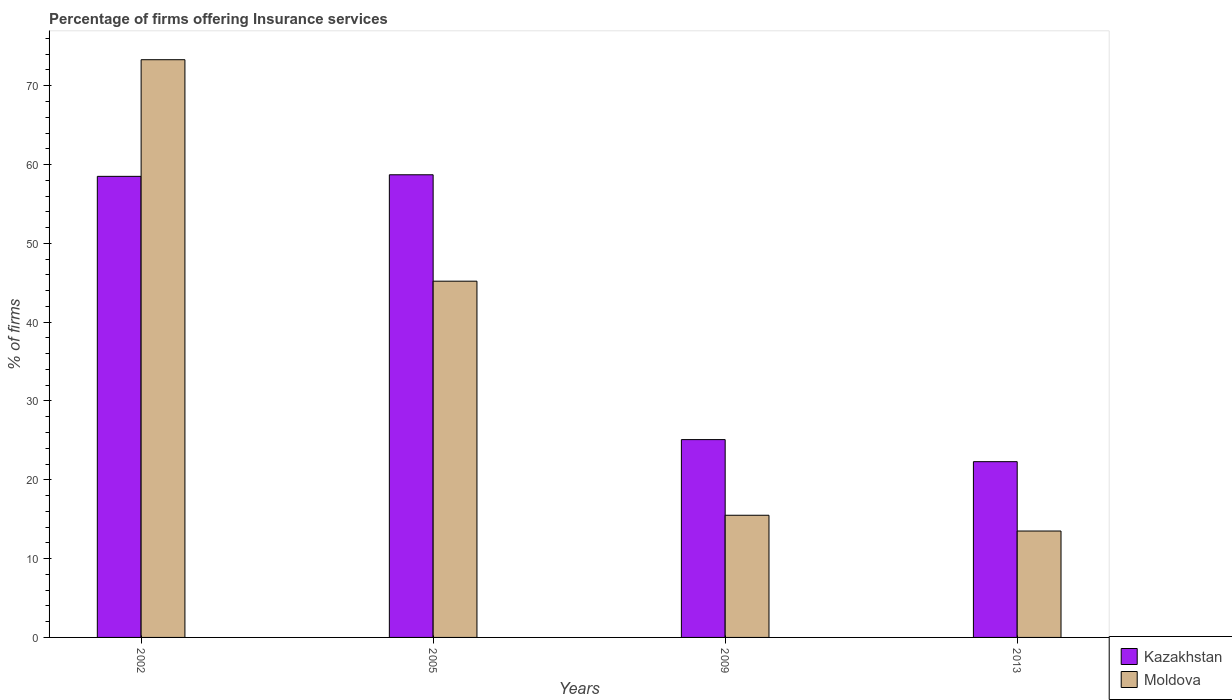How many different coloured bars are there?
Provide a short and direct response. 2. How many groups of bars are there?
Your answer should be compact. 4. Are the number of bars per tick equal to the number of legend labels?
Your answer should be very brief. Yes. How many bars are there on the 1st tick from the right?
Your answer should be very brief. 2. What is the label of the 2nd group of bars from the left?
Provide a short and direct response. 2005. What is the percentage of firms offering insurance services in Moldova in 2005?
Give a very brief answer. 45.2. Across all years, what is the maximum percentage of firms offering insurance services in Moldova?
Keep it short and to the point. 73.3. In which year was the percentage of firms offering insurance services in Kazakhstan maximum?
Ensure brevity in your answer.  2005. In which year was the percentage of firms offering insurance services in Kazakhstan minimum?
Your answer should be compact. 2013. What is the total percentage of firms offering insurance services in Moldova in the graph?
Give a very brief answer. 147.5. What is the difference between the percentage of firms offering insurance services in Moldova in 2002 and that in 2005?
Ensure brevity in your answer.  28.1. What is the difference between the percentage of firms offering insurance services in Kazakhstan in 2005 and the percentage of firms offering insurance services in Moldova in 2013?
Give a very brief answer. 45.2. What is the average percentage of firms offering insurance services in Kazakhstan per year?
Give a very brief answer. 41.15. In how many years, is the percentage of firms offering insurance services in Moldova greater than 30 %?
Provide a short and direct response. 2. What is the ratio of the percentage of firms offering insurance services in Moldova in 2002 to that in 2005?
Ensure brevity in your answer.  1.62. Is the percentage of firms offering insurance services in Kazakhstan in 2002 less than that in 2013?
Offer a very short reply. No. What is the difference between the highest and the second highest percentage of firms offering insurance services in Kazakhstan?
Your response must be concise. 0.2. What is the difference between the highest and the lowest percentage of firms offering insurance services in Kazakhstan?
Your answer should be very brief. 36.4. In how many years, is the percentage of firms offering insurance services in Moldova greater than the average percentage of firms offering insurance services in Moldova taken over all years?
Provide a succinct answer. 2. Is the sum of the percentage of firms offering insurance services in Kazakhstan in 2005 and 2013 greater than the maximum percentage of firms offering insurance services in Moldova across all years?
Your answer should be compact. Yes. What does the 1st bar from the left in 2013 represents?
Offer a terse response. Kazakhstan. What does the 2nd bar from the right in 2002 represents?
Your answer should be very brief. Kazakhstan. How many bars are there?
Your answer should be compact. 8. How many years are there in the graph?
Provide a succinct answer. 4. Are the values on the major ticks of Y-axis written in scientific E-notation?
Offer a terse response. No. Does the graph contain grids?
Provide a short and direct response. No. How many legend labels are there?
Offer a very short reply. 2. What is the title of the graph?
Offer a very short reply. Percentage of firms offering Insurance services. What is the label or title of the Y-axis?
Offer a terse response. % of firms. What is the % of firms of Kazakhstan in 2002?
Your response must be concise. 58.5. What is the % of firms of Moldova in 2002?
Your response must be concise. 73.3. What is the % of firms of Kazakhstan in 2005?
Offer a terse response. 58.7. What is the % of firms of Moldova in 2005?
Keep it short and to the point. 45.2. What is the % of firms of Kazakhstan in 2009?
Offer a terse response. 25.1. What is the % of firms of Kazakhstan in 2013?
Give a very brief answer. 22.3. What is the % of firms of Moldova in 2013?
Offer a very short reply. 13.5. Across all years, what is the maximum % of firms of Kazakhstan?
Give a very brief answer. 58.7. Across all years, what is the maximum % of firms of Moldova?
Your answer should be very brief. 73.3. Across all years, what is the minimum % of firms in Kazakhstan?
Keep it short and to the point. 22.3. What is the total % of firms in Kazakhstan in the graph?
Offer a terse response. 164.6. What is the total % of firms of Moldova in the graph?
Keep it short and to the point. 147.5. What is the difference between the % of firms of Moldova in 2002 and that in 2005?
Ensure brevity in your answer.  28.1. What is the difference between the % of firms in Kazakhstan in 2002 and that in 2009?
Offer a very short reply. 33.4. What is the difference between the % of firms in Moldova in 2002 and that in 2009?
Give a very brief answer. 57.8. What is the difference between the % of firms of Kazakhstan in 2002 and that in 2013?
Make the answer very short. 36.2. What is the difference between the % of firms in Moldova in 2002 and that in 2013?
Offer a terse response. 59.8. What is the difference between the % of firms of Kazakhstan in 2005 and that in 2009?
Provide a succinct answer. 33.6. What is the difference between the % of firms in Moldova in 2005 and that in 2009?
Your response must be concise. 29.7. What is the difference between the % of firms in Kazakhstan in 2005 and that in 2013?
Your answer should be very brief. 36.4. What is the difference between the % of firms in Moldova in 2005 and that in 2013?
Make the answer very short. 31.7. What is the difference between the % of firms in Moldova in 2009 and that in 2013?
Provide a short and direct response. 2. What is the difference between the % of firms of Kazakhstan in 2002 and the % of firms of Moldova in 2009?
Ensure brevity in your answer.  43. What is the difference between the % of firms of Kazakhstan in 2005 and the % of firms of Moldova in 2009?
Ensure brevity in your answer.  43.2. What is the difference between the % of firms of Kazakhstan in 2005 and the % of firms of Moldova in 2013?
Your answer should be very brief. 45.2. What is the average % of firms in Kazakhstan per year?
Provide a short and direct response. 41.15. What is the average % of firms of Moldova per year?
Offer a very short reply. 36.88. In the year 2002, what is the difference between the % of firms of Kazakhstan and % of firms of Moldova?
Offer a terse response. -14.8. In the year 2005, what is the difference between the % of firms in Kazakhstan and % of firms in Moldova?
Your answer should be very brief. 13.5. In the year 2013, what is the difference between the % of firms of Kazakhstan and % of firms of Moldova?
Keep it short and to the point. 8.8. What is the ratio of the % of firms of Kazakhstan in 2002 to that in 2005?
Give a very brief answer. 1. What is the ratio of the % of firms in Moldova in 2002 to that in 2005?
Make the answer very short. 1.62. What is the ratio of the % of firms of Kazakhstan in 2002 to that in 2009?
Offer a very short reply. 2.33. What is the ratio of the % of firms in Moldova in 2002 to that in 2009?
Provide a succinct answer. 4.73. What is the ratio of the % of firms of Kazakhstan in 2002 to that in 2013?
Keep it short and to the point. 2.62. What is the ratio of the % of firms in Moldova in 2002 to that in 2013?
Offer a very short reply. 5.43. What is the ratio of the % of firms in Kazakhstan in 2005 to that in 2009?
Offer a very short reply. 2.34. What is the ratio of the % of firms of Moldova in 2005 to that in 2009?
Your answer should be compact. 2.92. What is the ratio of the % of firms of Kazakhstan in 2005 to that in 2013?
Your answer should be very brief. 2.63. What is the ratio of the % of firms in Moldova in 2005 to that in 2013?
Provide a succinct answer. 3.35. What is the ratio of the % of firms in Kazakhstan in 2009 to that in 2013?
Provide a short and direct response. 1.13. What is the ratio of the % of firms in Moldova in 2009 to that in 2013?
Provide a short and direct response. 1.15. What is the difference between the highest and the second highest % of firms of Moldova?
Your answer should be compact. 28.1. What is the difference between the highest and the lowest % of firms in Kazakhstan?
Offer a very short reply. 36.4. What is the difference between the highest and the lowest % of firms of Moldova?
Provide a succinct answer. 59.8. 